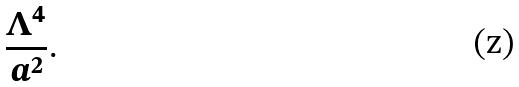Convert formula to latex. <formula><loc_0><loc_0><loc_500><loc_500>\frac { \Lambda ^ { 4 } } { a ^ { 2 } } .</formula> 